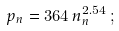<formula> <loc_0><loc_0><loc_500><loc_500>p _ { n } = 3 6 4 \, n _ { n } ^ { 2 . 5 4 } \, ;</formula> 